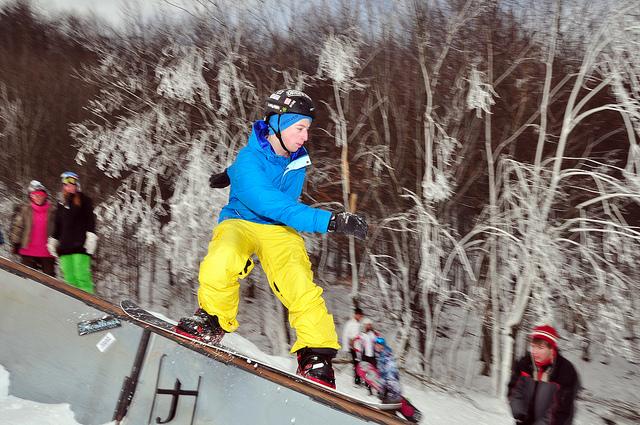Was this picture taken at night?
Answer briefly. No. Do the trees look frozen?
Quick response, please. Yes. Is this a man or woman?
Be succinct. Man. What trick is being performed?
Quick response, please. Grind. 